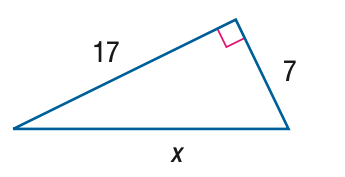Question: Find x.
Choices:
A. 4 \sqrt { 15 }
B. 13 \sqrt { 2 }
C. 13 \sqrt { 3 }
D. 8 \sqrt { 15 }
Answer with the letter. Answer: B 